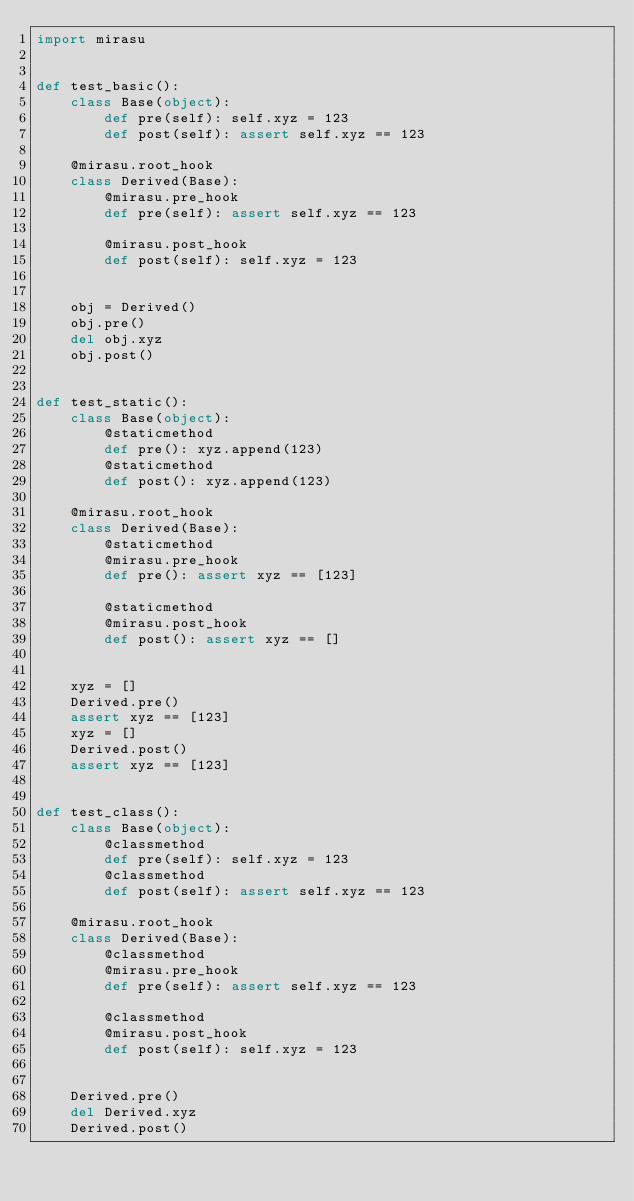<code> <loc_0><loc_0><loc_500><loc_500><_Python_>import mirasu


def test_basic():
    class Base(object):
        def pre(self): self.xyz = 123
        def post(self): assert self.xyz == 123

    @mirasu.root_hook
    class Derived(Base):
        @mirasu.pre_hook
        def pre(self): assert self.xyz == 123

        @mirasu.post_hook
        def post(self): self.xyz = 123


    obj = Derived()
    obj.pre()
    del obj.xyz
    obj.post()


def test_static():
    class Base(object):
        @staticmethod
        def pre(): xyz.append(123)
        @staticmethod
        def post(): xyz.append(123)

    @mirasu.root_hook
    class Derived(Base):
        @staticmethod
        @mirasu.pre_hook
        def pre(): assert xyz == [123]

        @staticmethod
        @mirasu.post_hook
        def post(): assert xyz == []


    xyz = []
    Derived.pre()
    assert xyz == [123]
    xyz = []
    Derived.post()
    assert xyz == [123]


def test_class():
    class Base(object):
        @classmethod
        def pre(self): self.xyz = 123
        @classmethod
        def post(self): assert self.xyz == 123

    @mirasu.root_hook
    class Derived(Base):
        @classmethod
        @mirasu.pre_hook
        def pre(self): assert self.xyz == 123

        @classmethod
        @mirasu.post_hook
        def post(self): self.xyz = 123


    Derived.pre()
    del Derived.xyz
    Derived.post()
</code> 